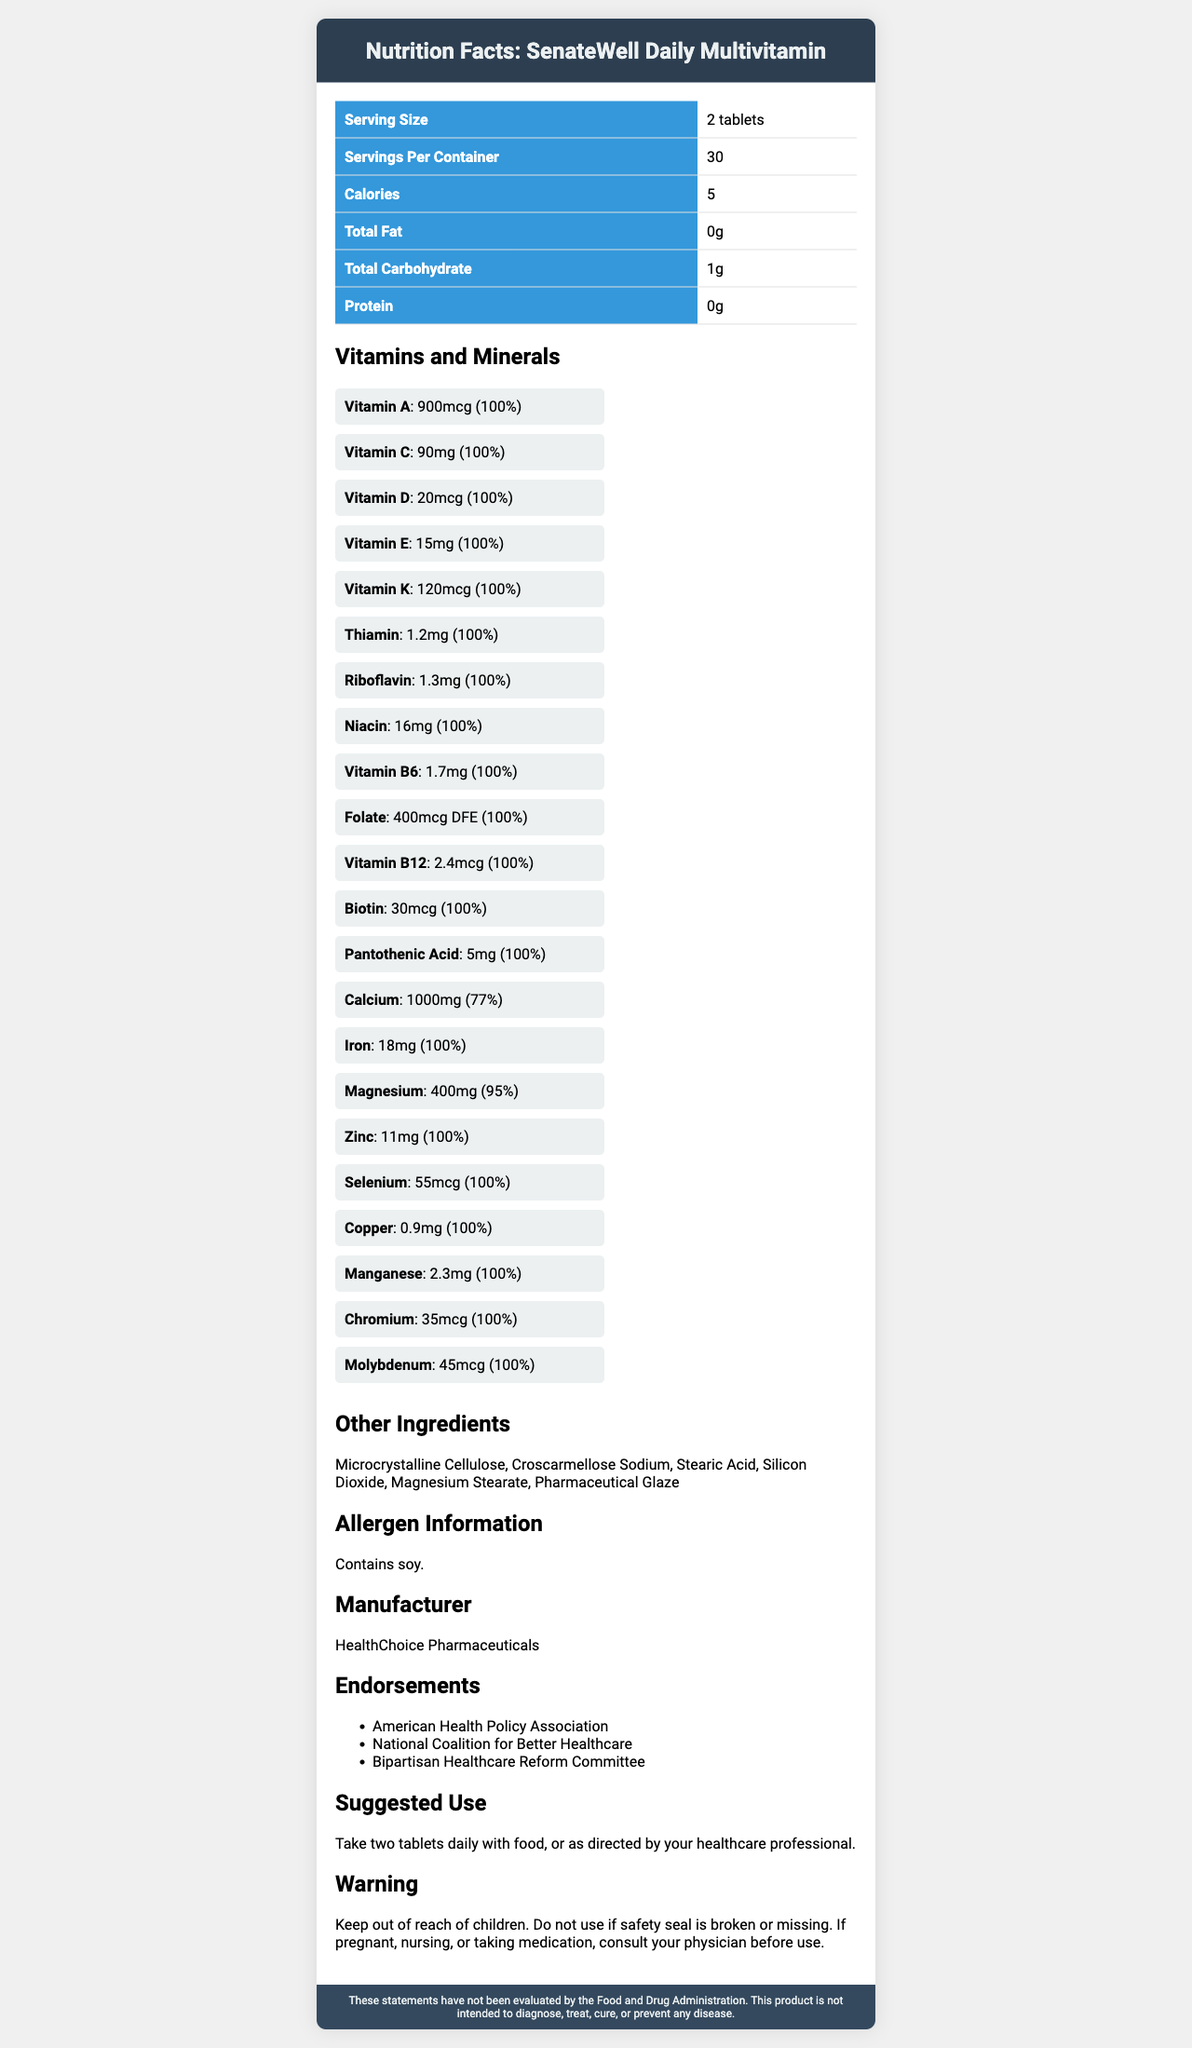what is the serving size for SenateWell Daily Multivitamin? The document states that the serving size is 2 tablets.
Answer: 2 tablets how many servings are in each container? The document provides the information that each container has 30 servings.
Answer: 30 servings how many calories are in a serving? The document specifies that there are 5 calories per serving.
Answer: 5 calories what percentage of the daily value for Calcium does this supplement provide? The document lists Calcium as providing 77% of the daily value.
Answer: 77% which vitamin has the lowest amount in mcg but covers 100% DV? The document shows Vitamin B12 at 2.4mcg, which is enough for 100% of the daily value.
Answer: Vitamin B12 which of the following vitamins is not listed in the supplement? A. Vitamin C B. Vitamin D C. Vitamin B17 D. Vitamin K The list of vitamins specified in the document does not include Vitamin B17.
Answer: C. Vitamin B17 what is the main caution mentioned in the warning section? The warning prominently mentions to keep the supplement out of reach of children.
Answer: Keep out of reach of children. who is the manufacturer of SenateWell Daily Multivitamin? According to the document, the manufacturer is HealthChoice Pharmaceuticals.
Answer: HealthChoice Pharmaceuticals is the allergen information available? The document specifies that the supplement contains soy.
Answer: Yes based on the endorsements, which organizations support this product? A. National Health Alliance B. American Health Policy Association C. Fitness and Wellness Foundation D. Pediatric Nutrition Society The document lists the American Health Policy Association as one of the endorsing organizations.
Answer: B. American Health Policy Association how often should this supplement be taken? The suggested use in the document advises taking two tablets daily with food or as directed by a healthcare professional.
Answer: Two tablets daily is this product intended to diagnose, treat, cure, or prevent any disease? The disclaimer states that the product is not intended to diagnose, treat, cure, or prevent any disease.
Answer: No summarize the key information provided in the document. The supplement provides extensive nutritional support through its content of essential vitamins and minerals, making it a comprehensive multivitamin endorsed by notable healthcare entities. It requires careful usage as per guidelines mentioned.
Answer: The SenateWell Daily Multivitamin is a dietary supplement with a serving size of 2 tablets, offering 30 servings per container. It includes a variety of vitamins and minerals, many of which provide 100% of the daily value. Endorsed by several healthcare organizations, it is manufactured by HealthChoice Pharmaceuticals. The supplement contains soy and has a number of other ingredients. Warnings related to usage and storage are provided, and it is noted that this product is not evaluated by the FDA for disease-related claims. does the supplement contain fish oil? The document does not provide any information regarding the presence of fish oil.
Answer: Cannot be determined 